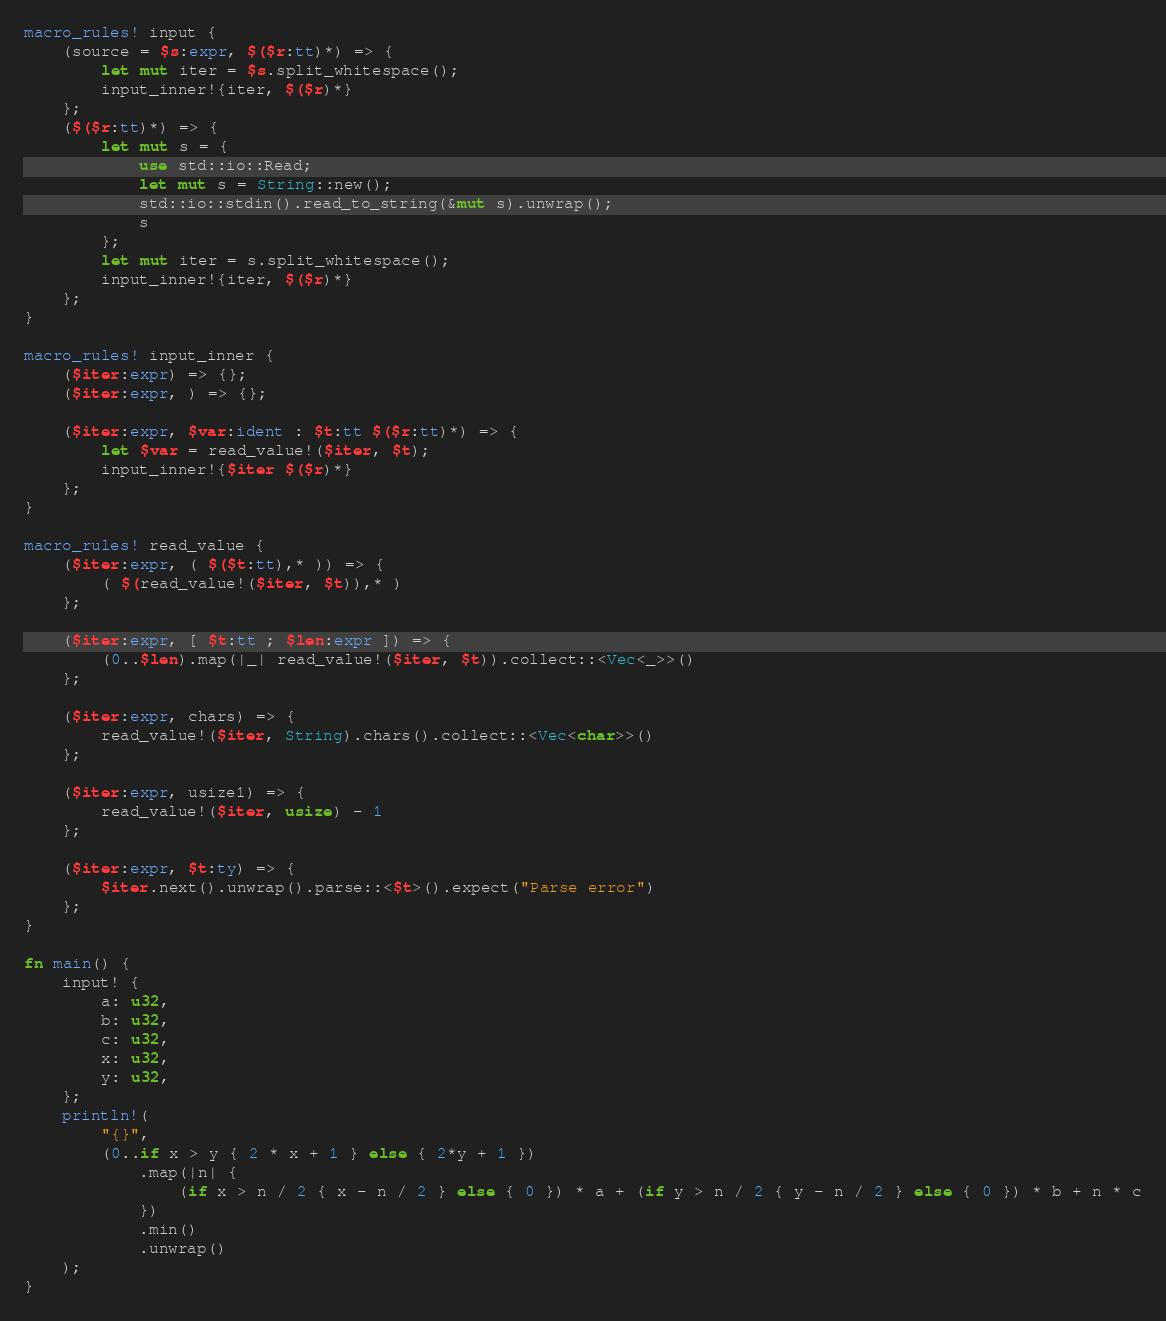Convert code to text. <code><loc_0><loc_0><loc_500><loc_500><_Rust_>macro_rules! input {
    (source = $s:expr, $($r:tt)*) => {
        let mut iter = $s.split_whitespace();
        input_inner!{iter, $($r)*}
    };
    ($($r:tt)*) => {
        let mut s = {
            use std::io::Read;
            let mut s = String::new();
            std::io::stdin().read_to_string(&mut s).unwrap();
            s
        };
        let mut iter = s.split_whitespace();
        input_inner!{iter, $($r)*}
    };
}

macro_rules! input_inner {
    ($iter:expr) => {};
    ($iter:expr, ) => {};

    ($iter:expr, $var:ident : $t:tt $($r:tt)*) => {
        let $var = read_value!($iter, $t);
        input_inner!{$iter $($r)*}
    };
}

macro_rules! read_value {
    ($iter:expr, ( $($t:tt),* )) => {
        ( $(read_value!($iter, $t)),* )
    };

    ($iter:expr, [ $t:tt ; $len:expr ]) => {
        (0..$len).map(|_| read_value!($iter, $t)).collect::<Vec<_>>()
    };

    ($iter:expr, chars) => {
        read_value!($iter, String).chars().collect::<Vec<char>>()
    };

    ($iter:expr, usize1) => {
        read_value!($iter, usize) - 1
    };

    ($iter:expr, $t:ty) => {
        $iter.next().unwrap().parse::<$t>().expect("Parse error")
    };
}

fn main() {
    input! {
        a: u32,
        b: u32,
        c: u32,
        x: u32,
        y: u32,
    };
    println!(
        "{}",
        (0..if x > y { 2 * x + 1 } else { 2*y + 1 })
            .map(|n| {
                (if x > n / 2 { x - n / 2 } else { 0 }) * a + (if y > n / 2 { y - n / 2 } else { 0 }) * b + n * c
            })
            .min()
            .unwrap()
    );
}
</code> 